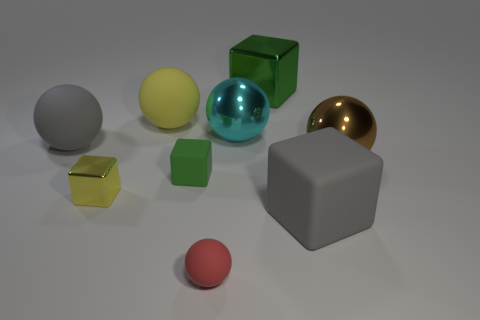Is the number of shiny cubes to the left of the large cyan shiny sphere less than the number of small yellow cubes?
Keep it short and to the point. No. How many red spheres are there?
Your answer should be very brief. 1. There is a large green object; does it have the same shape as the green object that is on the left side of the tiny ball?
Offer a terse response. Yes. Are there fewer large gray things on the right side of the tiny rubber cube than large matte things that are behind the gray matte block?
Your answer should be compact. Yes. Are there any other things that are the same shape as the red rubber object?
Your response must be concise. Yes. Is the shape of the yellow rubber thing the same as the cyan shiny object?
Offer a very short reply. Yes. Is there any other thing that is the same material as the gray ball?
Offer a terse response. Yes. What is the size of the green metallic object?
Make the answer very short. Large. What is the color of the sphere that is in front of the gray ball and to the left of the large brown metal sphere?
Your answer should be compact. Red. Are there more small green blocks than cubes?
Ensure brevity in your answer.  No. 